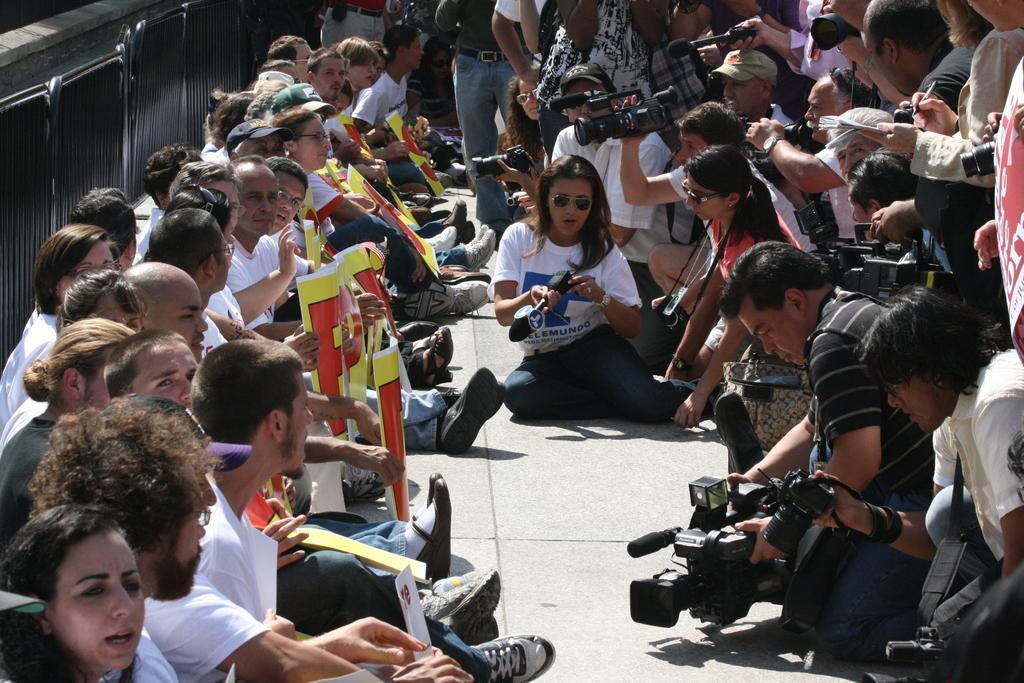Please provide a concise description of this image. In this image I can see on the left side a group of people are sitting on the floor, they are wearing white color t-shirts. On the right side a group of people are holding the cameras and looking at the left side. 